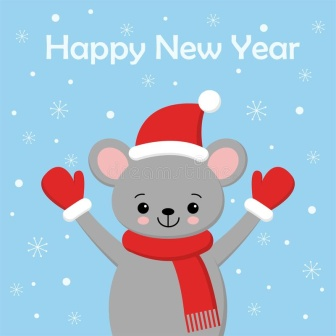Invent a story about the mouse’s adventures throughout the year leading up to this New Year celebration. Once upon a time, in a meadow far away, lived a little gray mouse named Merry. Merry’s year was filled with many adventures and heartwarming moments. At the start of the year, Merry discovered a hidden grove of winter berries which became a favorite spot for picnics. In spring, Merry helped the local bird community by finding strings and twigs for them to build their nests. Summer brought days of sunbathing and collecting fireflies, while autumn was spent gathering acorns and attending the grand Harvest Festival with all woodland creatures. With the onset of winter, Merry decided to prepare for the grand New Year celebration. Gathering special items from each season – flowers from spring, firefly lights from summer, and acorn décor from autumn – Merry created a uniquely decorated home. On New Year’s Eve, Merry wore its festive red mittens and Santa hat, welcoming friends with a grand feast and storytelling session about the fantastic adventures of the past year. As the clock struck midnight, Merry looked forward with hope and excitement to another year of unforgettable adventures. 